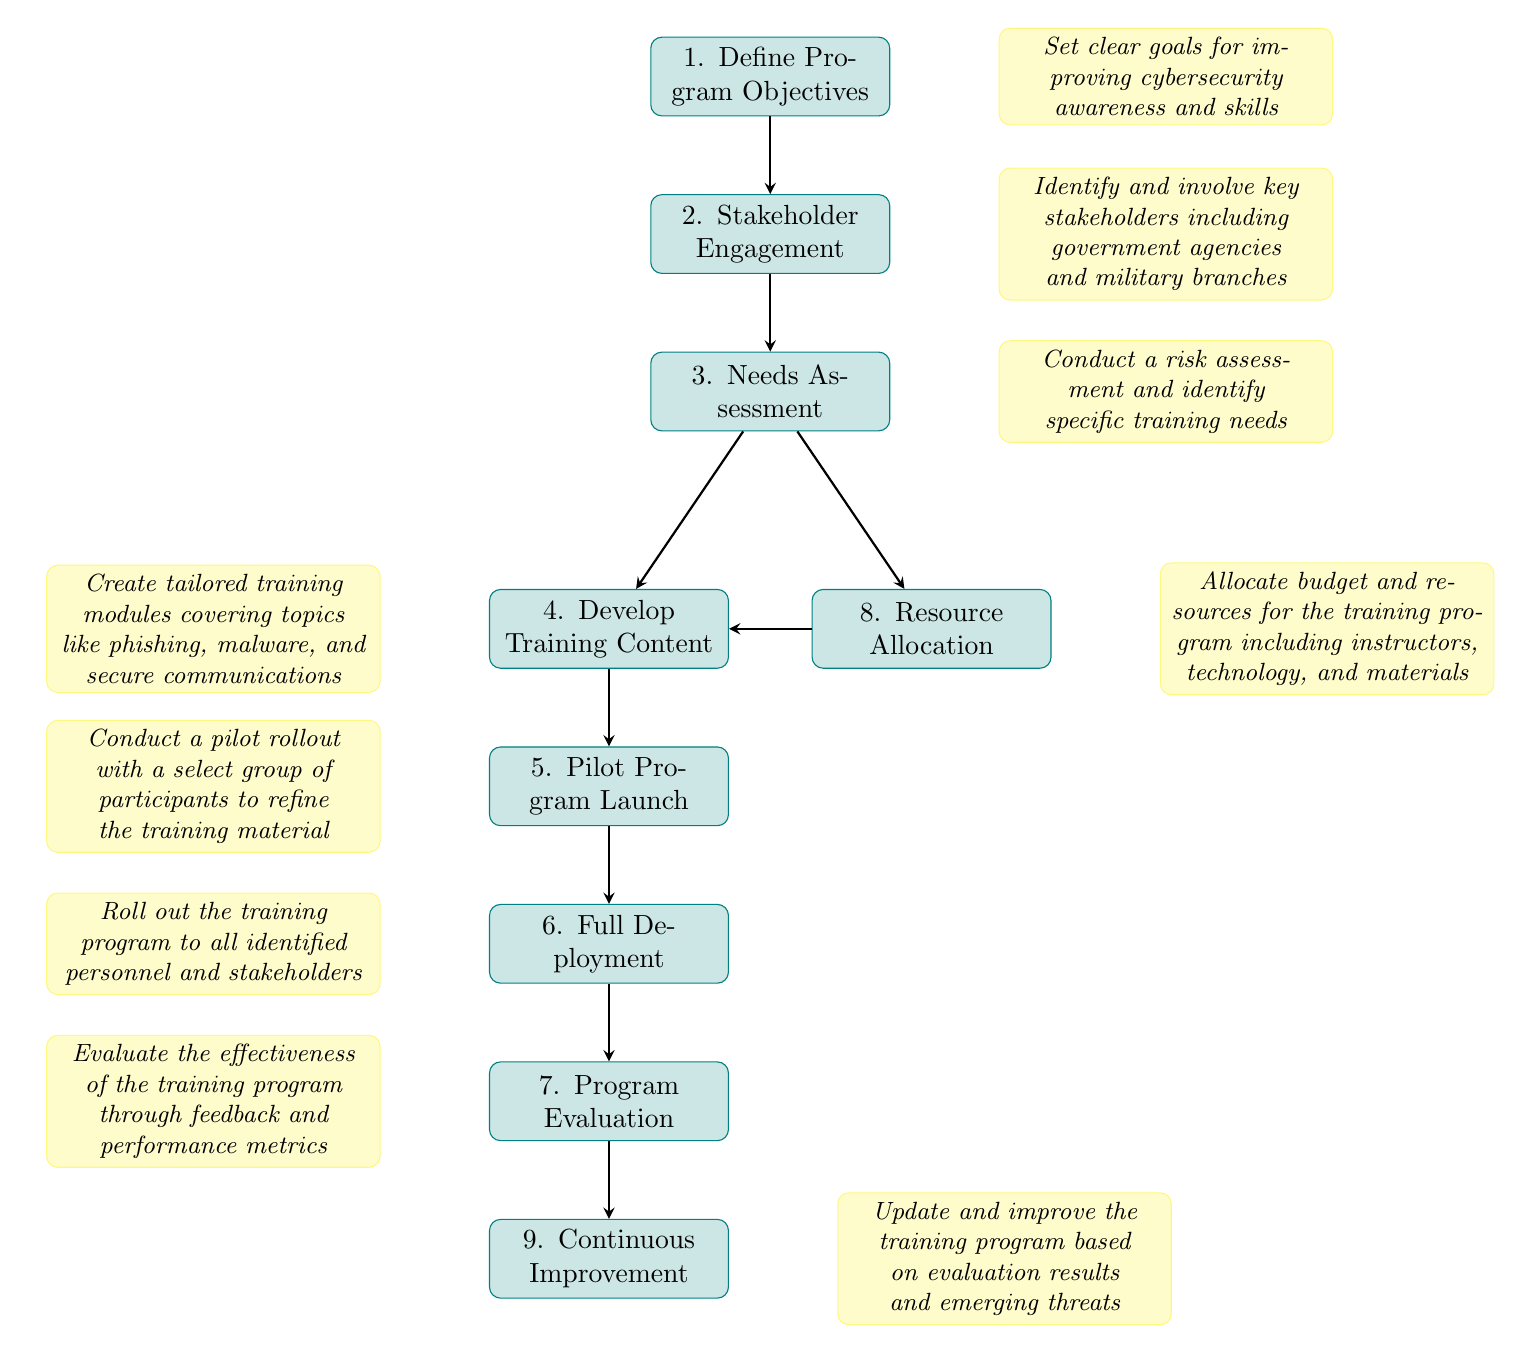What is the first step in the cybersecurity training program rollout? The first step is "Define Program Objectives," which sets the goals for improving cybersecurity awareness and skills.
Answer: Define Program Objectives How many nodes are in the diagram? The diagram contains nine nodes representing different steps in the program rollout process.
Answer: Nine Which node comes after "Full Deployment"? After "Full Deployment," the next node is "Program Evaluation."
Answer: Program Evaluation What are the two paths following "Needs Assessment"? The two paths following "Needs Assessment" lead to "Develop Training Content" and "Resource Allocation."
Answer: Develop Training Content, Resource Allocation What is the purpose of the "Pilot Program Launch"? The purpose of the "Pilot Program Launch" is to conduct a pilot rollout with a select group of participants to refine the training material.
Answer: Conduct a pilot rollout with a select group of participants to refine the training material In what step is budget allocation addressed? Budget allocation is addressed in the "Resource Allocation" step, where budget and resources for the training program are allocated.
Answer: Resource Allocation What are the final two steps in the diagram? The final two steps in the diagram are "Program Evaluation" followed by "Continuous Improvement."
Answer: Program Evaluation, Continuous Improvement Which step involves creating tailored training modules? The step that involves creating tailored training modules is "Develop Training Content."
Answer: Develop Training Content What is the relationship between "Needs Assessment" and "Resource Allocation"? "Needs Assessment" has two paths: one leads to "Develop Training Content" and the other leads to "Resource Allocation," indicating that resource allocation is informed by the needs identified.
Answer: Two paths from "Needs Assessment" to "Develop Training Content" and "Resource Allocation" 